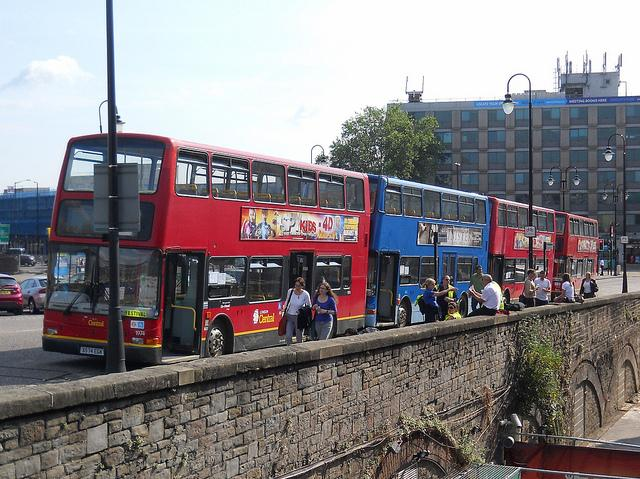Who is the queen of this territory? Please explain your reasoning. elizabeth ii. The double decker buses are typical of london. elizabeth ii is the queen of england, where london is. 